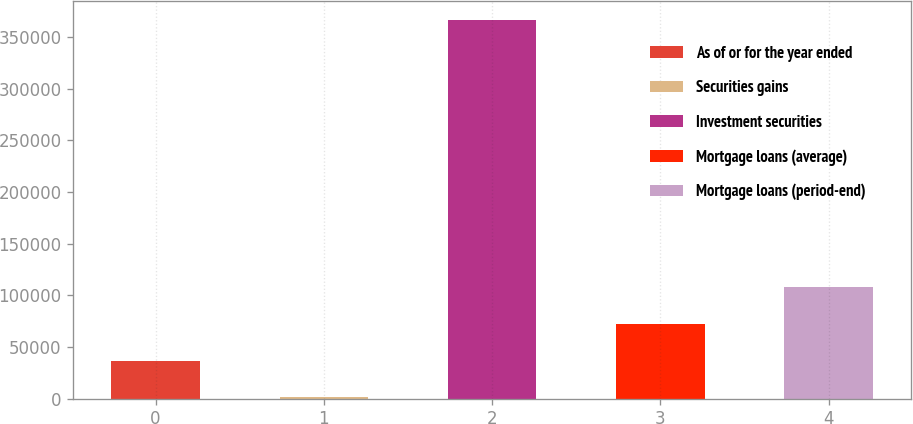<chart> <loc_0><loc_0><loc_500><loc_500><bar_chart><fcel>As of or for the year ended<fcel>Securities gains<fcel>Investment securities<fcel>Mortgage loans (average)<fcel>Mortgage loans (period-end)<nl><fcel>36807<fcel>1385<fcel>366307<fcel>72229<fcel>107651<nl></chart> 